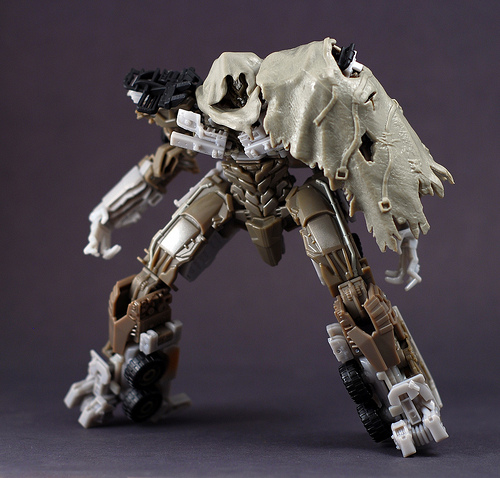<image>
Can you confirm if the action figure is on the shadow? Yes. Looking at the image, I can see the action figure is positioned on top of the shadow, with the shadow providing support. 